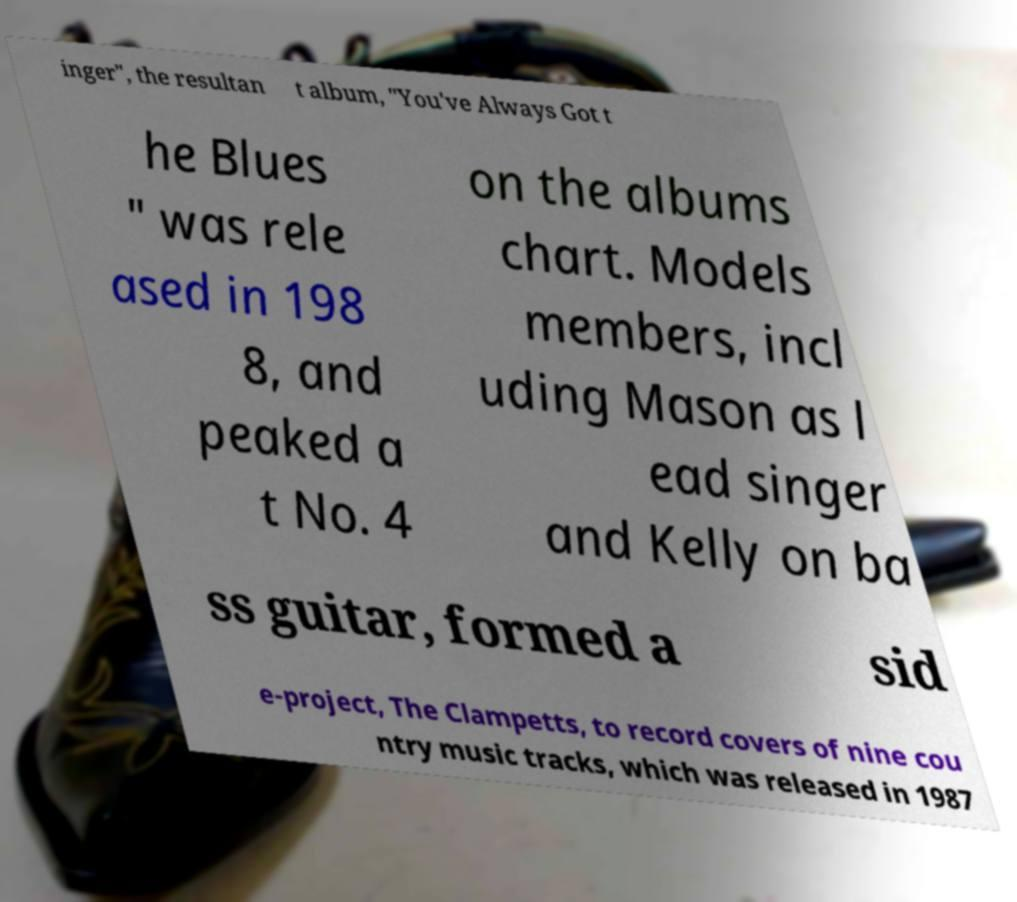Can you read and provide the text displayed in the image?This photo seems to have some interesting text. Can you extract and type it out for me? inger", the resultan t album, "You've Always Got t he Blues " was rele ased in 198 8, and peaked a t No. 4 on the albums chart. Models members, incl uding Mason as l ead singer and Kelly on ba ss guitar, formed a sid e-project, The Clampetts, to record covers of nine cou ntry music tracks, which was released in 1987 